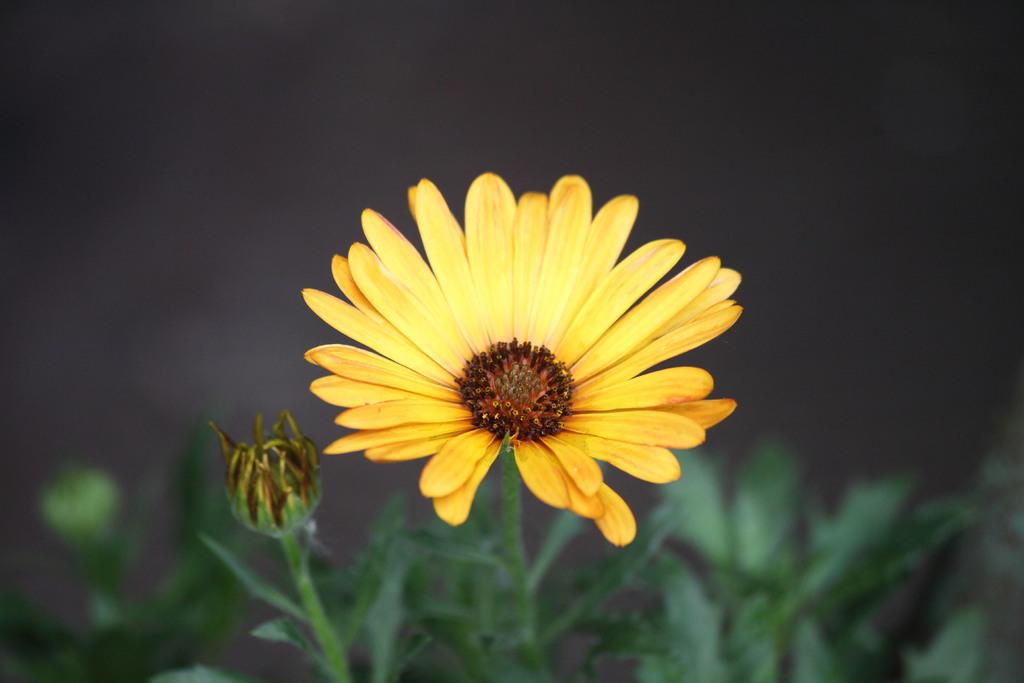What type of living organisms can be seen in the image? Plants can be seen in the image. What color are the flowers on the plants? The flowers on the plants are yellow. Can you describe any other features of the plants in the image? There is a bud beside the plants. What type of reward is the plant receiving for its good behavior in the image? There is no indication in the image that the plant is receiving a reward or exhibiting any behavior, as plants do not have the ability to behave or receive rewards. 